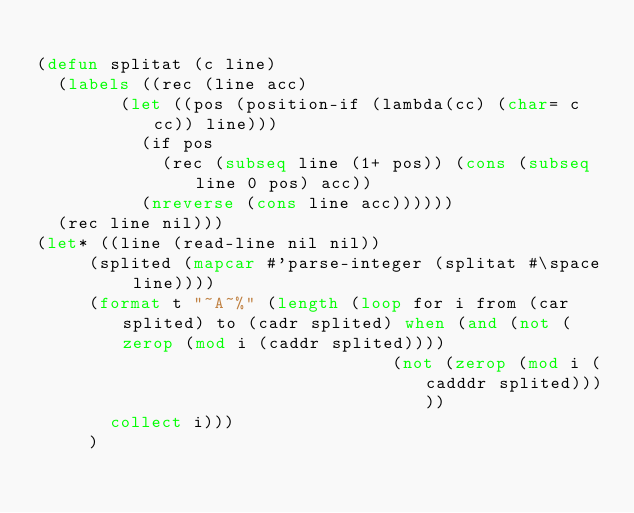Convert code to text. <code><loc_0><loc_0><loc_500><loc_500><_Lisp_>
(defun splitat (c line)
  (labels ((rec (line acc)
				(let ((pos (position-if (lambda(cc) (char= c cc)) line)))
				  (if pos
					  (rec (subseq line (1+ pos)) (cons (subseq line 0 pos) acc))
					(nreverse (cons line acc))))))
	(rec line nil)))
(let* ((line (read-line nil nil))
	   (splited (mapcar #'parse-integer (splitat #\space line))))
	   (format t "~A~%" (length (loop for i from (car splited) to (cadr splited) when (and (not (zerop (mod i (caddr splited))))
																  (not (zerop (mod i (cadddr splited)))))
			 collect i)))
	   )</code> 